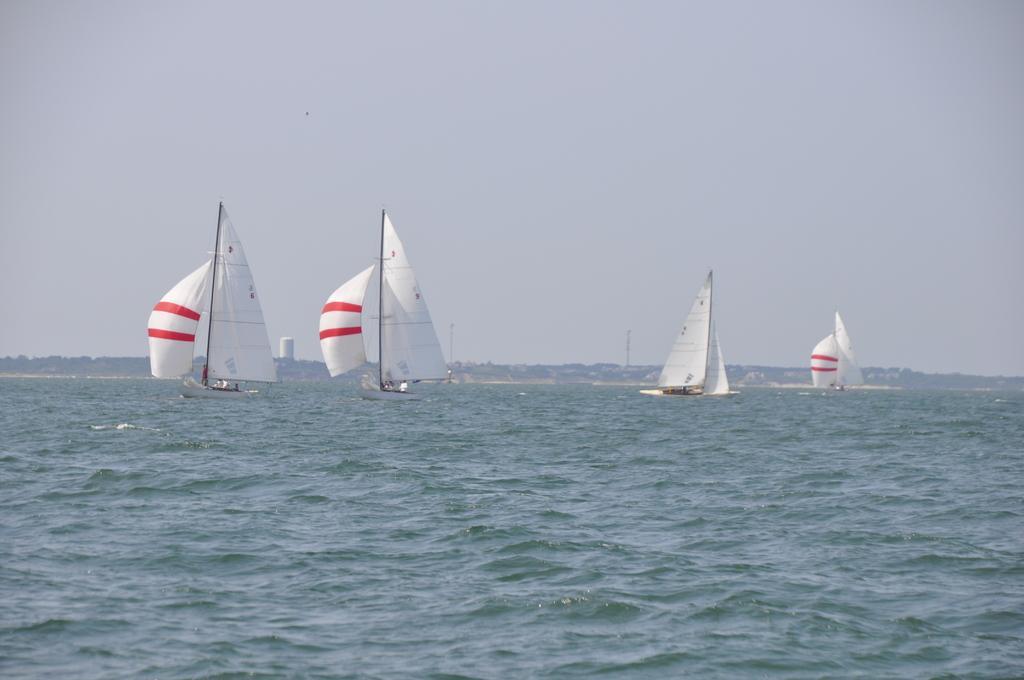Please provide a concise description of this image. In this image I can see a group of people in the boats and water. In the background I can see trees, towers, buildings and the sky. This image is taken may be in the ocean. 